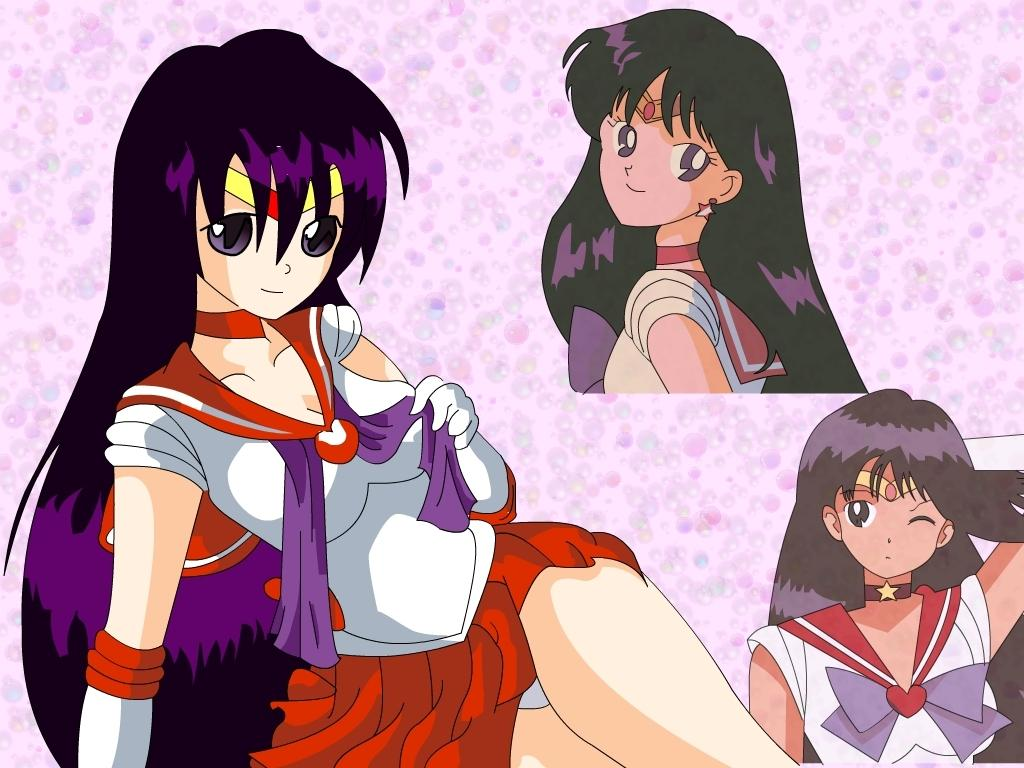What type of picture is shown in the image? The image is an animated picture. What kind of characters can be seen in the image? There are cartoons in the image. What creature is sneezing in the image? There is no creature present in the image, and no one is sneezing. 